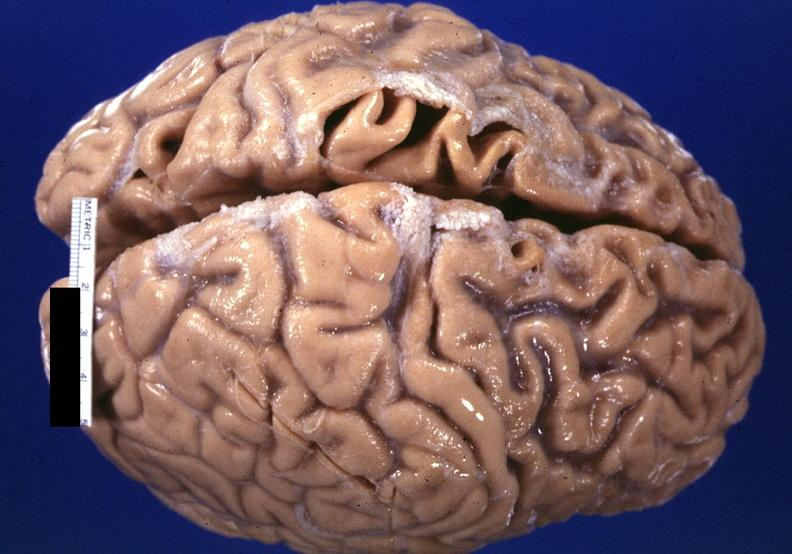s mucinous cystadenocarcinoma present?
Answer the question using a single word or phrase. No 